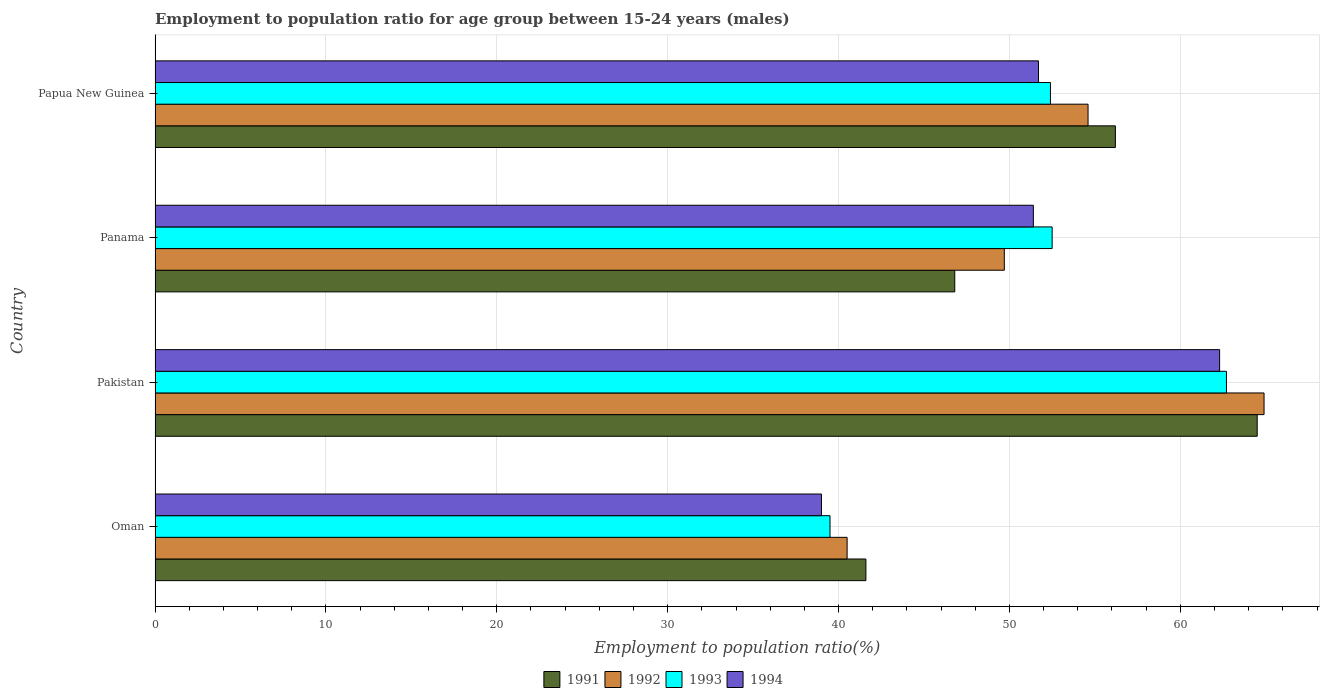How many groups of bars are there?
Provide a succinct answer. 4. Are the number of bars per tick equal to the number of legend labels?
Provide a short and direct response. Yes. Are the number of bars on each tick of the Y-axis equal?
Provide a short and direct response. Yes. How many bars are there on the 3rd tick from the top?
Offer a very short reply. 4. How many bars are there on the 4th tick from the bottom?
Provide a succinct answer. 4. What is the employment to population ratio in 1991 in Pakistan?
Keep it short and to the point. 64.5. Across all countries, what is the maximum employment to population ratio in 1994?
Provide a short and direct response. 62.3. In which country was the employment to population ratio in 1994 maximum?
Offer a very short reply. Pakistan. In which country was the employment to population ratio in 1992 minimum?
Provide a succinct answer. Oman. What is the total employment to population ratio in 1992 in the graph?
Provide a succinct answer. 209.7. What is the difference between the employment to population ratio in 1991 in Panama and that in Papua New Guinea?
Offer a terse response. -9.4. What is the difference between the employment to population ratio in 1993 in Papua New Guinea and the employment to population ratio in 1994 in Panama?
Offer a very short reply. 1. What is the average employment to population ratio in 1994 per country?
Give a very brief answer. 51.1. What is the difference between the employment to population ratio in 1994 and employment to population ratio in 1993 in Oman?
Your response must be concise. -0.5. In how many countries, is the employment to population ratio in 1991 greater than 22 %?
Your response must be concise. 4. What is the ratio of the employment to population ratio in 1993 in Oman to that in Papua New Guinea?
Provide a succinct answer. 0.75. Is the employment to population ratio in 1992 in Oman less than that in Panama?
Give a very brief answer. Yes. Is the difference between the employment to population ratio in 1994 in Oman and Papua New Guinea greater than the difference between the employment to population ratio in 1993 in Oman and Papua New Guinea?
Keep it short and to the point. Yes. What is the difference between the highest and the second highest employment to population ratio in 1992?
Keep it short and to the point. 10.3. What is the difference between the highest and the lowest employment to population ratio in 1992?
Your response must be concise. 24.4. Is the sum of the employment to population ratio in 1991 in Pakistan and Panama greater than the maximum employment to population ratio in 1992 across all countries?
Ensure brevity in your answer.  Yes. Is it the case that in every country, the sum of the employment to population ratio in 1993 and employment to population ratio in 1991 is greater than the sum of employment to population ratio in 1992 and employment to population ratio in 1994?
Ensure brevity in your answer.  No. What does the 2nd bar from the top in Pakistan represents?
Your answer should be very brief. 1993. What does the 1st bar from the bottom in Pakistan represents?
Keep it short and to the point. 1991. Are the values on the major ticks of X-axis written in scientific E-notation?
Give a very brief answer. No. Does the graph contain any zero values?
Keep it short and to the point. No. Where does the legend appear in the graph?
Give a very brief answer. Bottom center. How are the legend labels stacked?
Offer a terse response. Horizontal. What is the title of the graph?
Offer a very short reply. Employment to population ratio for age group between 15-24 years (males). Does "1996" appear as one of the legend labels in the graph?
Keep it short and to the point. No. What is the label or title of the X-axis?
Offer a very short reply. Employment to population ratio(%). What is the label or title of the Y-axis?
Keep it short and to the point. Country. What is the Employment to population ratio(%) of 1991 in Oman?
Make the answer very short. 41.6. What is the Employment to population ratio(%) of 1992 in Oman?
Your answer should be very brief. 40.5. What is the Employment to population ratio(%) of 1993 in Oman?
Your answer should be compact. 39.5. What is the Employment to population ratio(%) in 1991 in Pakistan?
Your answer should be compact. 64.5. What is the Employment to population ratio(%) in 1992 in Pakistan?
Ensure brevity in your answer.  64.9. What is the Employment to population ratio(%) in 1993 in Pakistan?
Provide a succinct answer. 62.7. What is the Employment to population ratio(%) of 1994 in Pakistan?
Offer a very short reply. 62.3. What is the Employment to population ratio(%) in 1991 in Panama?
Your answer should be very brief. 46.8. What is the Employment to population ratio(%) of 1992 in Panama?
Provide a succinct answer. 49.7. What is the Employment to population ratio(%) of 1993 in Panama?
Your response must be concise. 52.5. What is the Employment to population ratio(%) of 1994 in Panama?
Provide a short and direct response. 51.4. What is the Employment to population ratio(%) in 1991 in Papua New Guinea?
Make the answer very short. 56.2. What is the Employment to population ratio(%) of 1992 in Papua New Guinea?
Ensure brevity in your answer.  54.6. What is the Employment to population ratio(%) of 1993 in Papua New Guinea?
Provide a short and direct response. 52.4. What is the Employment to population ratio(%) in 1994 in Papua New Guinea?
Your answer should be compact. 51.7. Across all countries, what is the maximum Employment to population ratio(%) of 1991?
Give a very brief answer. 64.5. Across all countries, what is the maximum Employment to population ratio(%) of 1992?
Provide a short and direct response. 64.9. Across all countries, what is the maximum Employment to population ratio(%) in 1993?
Offer a terse response. 62.7. Across all countries, what is the maximum Employment to population ratio(%) of 1994?
Your answer should be very brief. 62.3. Across all countries, what is the minimum Employment to population ratio(%) in 1991?
Your answer should be compact. 41.6. Across all countries, what is the minimum Employment to population ratio(%) of 1992?
Keep it short and to the point. 40.5. Across all countries, what is the minimum Employment to population ratio(%) of 1993?
Offer a very short reply. 39.5. Across all countries, what is the minimum Employment to population ratio(%) of 1994?
Offer a terse response. 39. What is the total Employment to population ratio(%) of 1991 in the graph?
Ensure brevity in your answer.  209.1. What is the total Employment to population ratio(%) in 1992 in the graph?
Your response must be concise. 209.7. What is the total Employment to population ratio(%) in 1993 in the graph?
Provide a succinct answer. 207.1. What is the total Employment to population ratio(%) in 1994 in the graph?
Your answer should be compact. 204.4. What is the difference between the Employment to population ratio(%) in 1991 in Oman and that in Pakistan?
Your response must be concise. -22.9. What is the difference between the Employment to population ratio(%) of 1992 in Oman and that in Pakistan?
Give a very brief answer. -24.4. What is the difference between the Employment to population ratio(%) in 1993 in Oman and that in Pakistan?
Your answer should be compact. -23.2. What is the difference between the Employment to population ratio(%) in 1994 in Oman and that in Pakistan?
Make the answer very short. -23.3. What is the difference between the Employment to population ratio(%) in 1992 in Oman and that in Panama?
Keep it short and to the point. -9.2. What is the difference between the Employment to population ratio(%) in 1994 in Oman and that in Panama?
Make the answer very short. -12.4. What is the difference between the Employment to population ratio(%) of 1991 in Oman and that in Papua New Guinea?
Make the answer very short. -14.6. What is the difference between the Employment to population ratio(%) in 1992 in Oman and that in Papua New Guinea?
Keep it short and to the point. -14.1. What is the difference between the Employment to population ratio(%) in 1994 in Oman and that in Papua New Guinea?
Keep it short and to the point. -12.7. What is the difference between the Employment to population ratio(%) of 1992 in Pakistan and that in Panama?
Ensure brevity in your answer.  15.2. What is the difference between the Employment to population ratio(%) in 1993 in Pakistan and that in Panama?
Your answer should be very brief. 10.2. What is the difference between the Employment to population ratio(%) in 1992 in Pakistan and that in Papua New Guinea?
Make the answer very short. 10.3. What is the difference between the Employment to population ratio(%) of 1993 in Pakistan and that in Papua New Guinea?
Your answer should be very brief. 10.3. What is the difference between the Employment to population ratio(%) in 1994 in Pakistan and that in Papua New Guinea?
Give a very brief answer. 10.6. What is the difference between the Employment to population ratio(%) in 1992 in Panama and that in Papua New Guinea?
Keep it short and to the point. -4.9. What is the difference between the Employment to population ratio(%) of 1994 in Panama and that in Papua New Guinea?
Give a very brief answer. -0.3. What is the difference between the Employment to population ratio(%) of 1991 in Oman and the Employment to population ratio(%) of 1992 in Pakistan?
Provide a short and direct response. -23.3. What is the difference between the Employment to population ratio(%) in 1991 in Oman and the Employment to population ratio(%) in 1993 in Pakistan?
Your response must be concise. -21.1. What is the difference between the Employment to population ratio(%) of 1991 in Oman and the Employment to population ratio(%) of 1994 in Pakistan?
Ensure brevity in your answer.  -20.7. What is the difference between the Employment to population ratio(%) of 1992 in Oman and the Employment to population ratio(%) of 1993 in Pakistan?
Provide a succinct answer. -22.2. What is the difference between the Employment to population ratio(%) of 1992 in Oman and the Employment to population ratio(%) of 1994 in Pakistan?
Keep it short and to the point. -21.8. What is the difference between the Employment to population ratio(%) of 1993 in Oman and the Employment to population ratio(%) of 1994 in Pakistan?
Give a very brief answer. -22.8. What is the difference between the Employment to population ratio(%) of 1991 in Oman and the Employment to population ratio(%) of 1992 in Panama?
Offer a very short reply. -8.1. What is the difference between the Employment to population ratio(%) of 1991 in Oman and the Employment to population ratio(%) of 1993 in Panama?
Provide a short and direct response. -10.9. What is the difference between the Employment to population ratio(%) of 1991 in Oman and the Employment to population ratio(%) of 1994 in Panama?
Give a very brief answer. -9.8. What is the difference between the Employment to population ratio(%) in 1991 in Oman and the Employment to population ratio(%) in 1993 in Papua New Guinea?
Your response must be concise. -10.8. What is the difference between the Employment to population ratio(%) in 1991 in Oman and the Employment to population ratio(%) in 1994 in Papua New Guinea?
Your answer should be very brief. -10.1. What is the difference between the Employment to population ratio(%) of 1992 in Oman and the Employment to population ratio(%) of 1994 in Papua New Guinea?
Ensure brevity in your answer.  -11.2. What is the difference between the Employment to population ratio(%) in 1991 in Pakistan and the Employment to population ratio(%) in 1993 in Panama?
Provide a short and direct response. 12. What is the difference between the Employment to population ratio(%) of 1992 in Pakistan and the Employment to population ratio(%) of 1993 in Panama?
Provide a succinct answer. 12.4. What is the difference between the Employment to population ratio(%) of 1992 in Pakistan and the Employment to population ratio(%) of 1994 in Panama?
Offer a terse response. 13.5. What is the difference between the Employment to population ratio(%) of 1993 in Pakistan and the Employment to population ratio(%) of 1994 in Panama?
Give a very brief answer. 11.3. What is the difference between the Employment to population ratio(%) in 1991 in Pakistan and the Employment to population ratio(%) in 1992 in Papua New Guinea?
Your answer should be compact. 9.9. What is the difference between the Employment to population ratio(%) of 1991 in Pakistan and the Employment to population ratio(%) of 1993 in Papua New Guinea?
Ensure brevity in your answer.  12.1. What is the difference between the Employment to population ratio(%) in 1992 in Pakistan and the Employment to population ratio(%) in 1993 in Papua New Guinea?
Give a very brief answer. 12.5. What is the difference between the Employment to population ratio(%) in 1992 in Pakistan and the Employment to population ratio(%) in 1994 in Papua New Guinea?
Offer a very short reply. 13.2. What is the difference between the Employment to population ratio(%) in 1993 in Pakistan and the Employment to population ratio(%) in 1994 in Papua New Guinea?
Offer a very short reply. 11. What is the difference between the Employment to population ratio(%) of 1991 in Panama and the Employment to population ratio(%) of 1993 in Papua New Guinea?
Your response must be concise. -5.6. What is the difference between the Employment to population ratio(%) of 1992 in Panama and the Employment to population ratio(%) of 1994 in Papua New Guinea?
Offer a very short reply. -2. What is the difference between the Employment to population ratio(%) of 1993 in Panama and the Employment to population ratio(%) of 1994 in Papua New Guinea?
Your response must be concise. 0.8. What is the average Employment to population ratio(%) in 1991 per country?
Your response must be concise. 52.27. What is the average Employment to population ratio(%) in 1992 per country?
Offer a very short reply. 52.42. What is the average Employment to population ratio(%) in 1993 per country?
Give a very brief answer. 51.77. What is the average Employment to population ratio(%) in 1994 per country?
Offer a very short reply. 51.1. What is the difference between the Employment to population ratio(%) of 1992 and Employment to population ratio(%) of 1993 in Oman?
Offer a very short reply. 1. What is the difference between the Employment to population ratio(%) in 1991 and Employment to population ratio(%) in 1992 in Pakistan?
Your answer should be compact. -0.4. What is the difference between the Employment to population ratio(%) of 1991 and Employment to population ratio(%) of 1994 in Pakistan?
Provide a succinct answer. 2.2. What is the difference between the Employment to population ratio(%) in 1992 and Employment to population ratio(%) in 1994 in Pakistan?
Keep it short and to the point. 2.6. What is the difference between the Employment to population ratio(%) in 1993 and Employment to population ratio(%) in 1994 in Pakistan?
Keep it short and to the point. 0.4. What is the difference between the Employment to population ratio(%) in 1991 and Employment to population ratio(%) in 1994 in Panama?
Your response must be concise. -4.6. What is the difference between the Employment to population ratio(%) in 1992 and Employment to population ratio(%) in 1993 in Panama?
Provide a short and direct response. -2.8. What is the difference between the Employment to population ratio(%) of 1991 and Employment to population ratio(%) of 1993 in Papua New Guinea?
Provide a succinct answer. 3.8. What is the difference between the Employment to population ratio(%) of 1991 and Employment to population ratio(%) of 1994 in Papua New Guinea?
Give a very brief answer. 4.5. What is the difference between the Employment to population ratio(%) in 1992 and Employment to population ratio(%) in 1993 in Papua New Guinea?
Provide a succinct answer. 2.2. What is the difference between the Employment to population ratio(%) of 1993 and Employment to population ratio(%) of 1994 in Papua New Guinea?
Your answer should be compact. 0.7. What is the ratio of the Employment to population ratio(%) in 1991 in Oman to that in Pakistan?
Offer a terse response. 0.65. What is the ratio of the Employment to population ratio(%) of 1992 in Oman to that in Pakistan?
Ensure brevity in your answer.  0.62. What is the ratio of the Employment to population ratio(%) of 1993 in Oman to that in Pakistan?
Offer a very short reply. 0.63. What is the ratio of the Employment to population ratio(%) of 1994 in Oman to that in Pakistan?
Your response must be concise. 0.63. What is the ratio of the Employment to population ratio(%) in 1992 in Oman to that in Panama?
Offer a very short reply. 0.81. What is the ratio of the Employment to population ratio(%) in 1993 in Oman to that in Panama?
Provide a succinct answer. 0.75. What is the ratio of the Employment to population ratio(%) in 1994 in Oman to that in Panama?
Make the answer very short. 0.76. What is the ratio of the Employment to population ratio(%) of 1991 in Oman to that in Papua New Guinea?
Provide a short and direct response. 0.74. What is the ratio of the Employment to population ratio(%) of 1992 in Oman to that in Papua New Guinea?
Provide a short and direct response. 0.74. What is the ratio of the Employment to population ratio(%) of 1993 in Oman to that in Papua New Guinea?
Keep it short and to the point. 0.75. What is the ratio of the Employment to population ratio(%) in 1994 in Oman to that in Papua New Guinea?
Your answer should be compact. 0.75. What is the ratio of the Employment to population ratio(%) in 1991 in Pakistan to that in Panama?
Your answer should be compact. 1.38. What is the ratio of the Employment to population ratio(%) in 1992 in Pakistan to that in Panama?
Your response must be concise. 1.31. What is the ratio of the Employment to population ratio(%) in 1993 in Pakistan to that in Panama?
Keep it short and to the point. 1.19. What is the ratio of the Employment to population ratio(%) in 1994 in Pakistan to that in Panama?
Ensure brevity in your answer.  1.21. What is the ratio of the Employment to population ratio(%) in 1991 in Pakistan to that in Papua New Guinea?
Provide a succinct answer. 1.15. What is the ratio of the Employment to population ratio(%) of 1992 in Pakistan to that in Papua New Guinea?
Your response must be concise. 1.19. What is the ratio of the Employment to population ratio(%) in 1993 in Pakistan to that in Papua New Guinea?
Your answer should be very brief. 1.2. What is the ratio of the Employment to population ratio(%) in 1994 in Pakistan to that in Papua New Guinea?
Your answer should be compact. 1.21. What is the ratio of the Employment to population ratio(%) in 1991 in Panama to that in Papua New Guinea?
Make the answer very short. 0.83. What is the ratio of the Employment to population ratio(%) of 1992 in Panama to that in Papua New Guinea?
Ensure brevity in your answer.  0.91. What is the ratio of the Employment to population ratio(%) of 1994 in Panama to that in Papua New Guinea?
Your answer should be compact. 0.99. What is the difference between the highest and the second highest Employment to population ratio(%) in 1991?
Give a very brief answer. 8.3. What is the difference between the highest and the second highest Employment to population ratio(%) of 1992?
Your answer should be compact. 10.3. What is the difference between the highest and the second highest Employment to population ratio(%) in 1993?
Offer a very short reply. 10.2. What is the difference between the highest and the lowest Employment to population ratio(%) of 1991?
Your response must be concise. 22.9. What is the difference between the highest and the lowest Employment to population ratio(%) of 1992?
Offer a terse response. 24.4. What is the difference between the highest and the lowest Employment to population ratio(%) of 1993?
Provide a short and direct response. 23.2. What is the difference between the highest and the lowest Employment to population ratio(%) of 1994?
Provide a short and direct response. 23.3. 